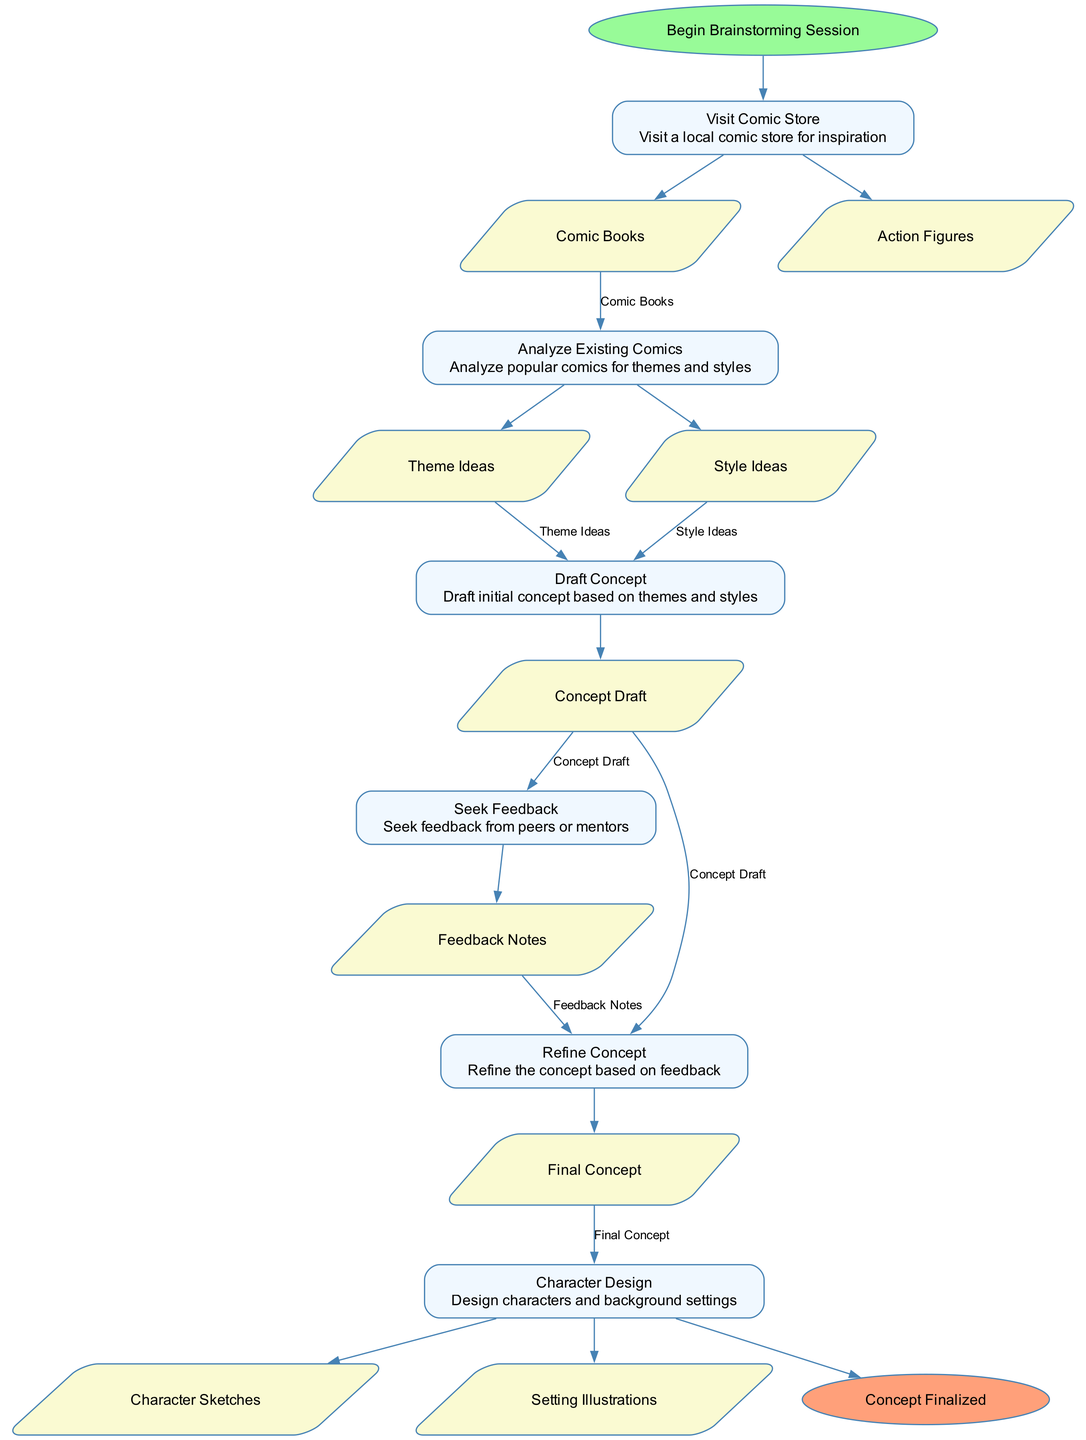What is the first action in the diagram? The first action node, following the start node, is "Visit Comic Store." This is determined by looking at the flow of the diagram, where actions follow the start node in the order they appear.
Answer: Visit Comic Store How many actions are there in the diagram? Counting the action nodes reveals there are six distinct actions shown in the diagram. This includes each node labeled with an action name.
Answer: 6 What outputs are generated from "Analyze Existing Comics"? "Analyze Existing Comics" generates two outputs: "Theme Ideas" and "Style Ideas." This is found in the details of the action node, which lists the outputs produced by each action.
Answer: Theme Ideas, Style Ideas Which action comes after "Draft Concept"? The action that follows "Draft Concept" is "Seek Feedback." By analyzing the sequence of action nodes, it's clear that "Seek Feedback" directly follows "Draft Concept."
Answer: Seek Feedback What is the final output of the process? The final output is represented as "Final Concept." This occurs at the end of the process after all actions have been completed and the concept has been refined.
Answer: Final Concept Which action has the most inputs? The action "Refine Concept" has the most inputs, which are "Concept Draft" and "Feedback Notes." By reviewing the inputs associated with each action, this is identified as having two inputs compared to others.
Answer: Refine Concept How does one go from generating ideas to character design? One moves from generating ideas to character design by completing the "Refine Concept" action, which leads to "Character Design." This progression is shown in the flow of actions from refining the concept to designing characters based on that final concept.
Answer: Character Design What is the last node before reaching the end of the diagram? The last node before reaching the end of the diagram is "Character Design." It's directly connected to the "End" node, marking it as the final action before concluding the process.
Answer: Character Design Which outputs are created at the "Character Design" action? The outputs from "Character Design" include "Character Sketches" and "Setting Illustrations." These are specified as results from the character design process detailed in that action node.
Answer: Character Sketches, Setting Illustrations 